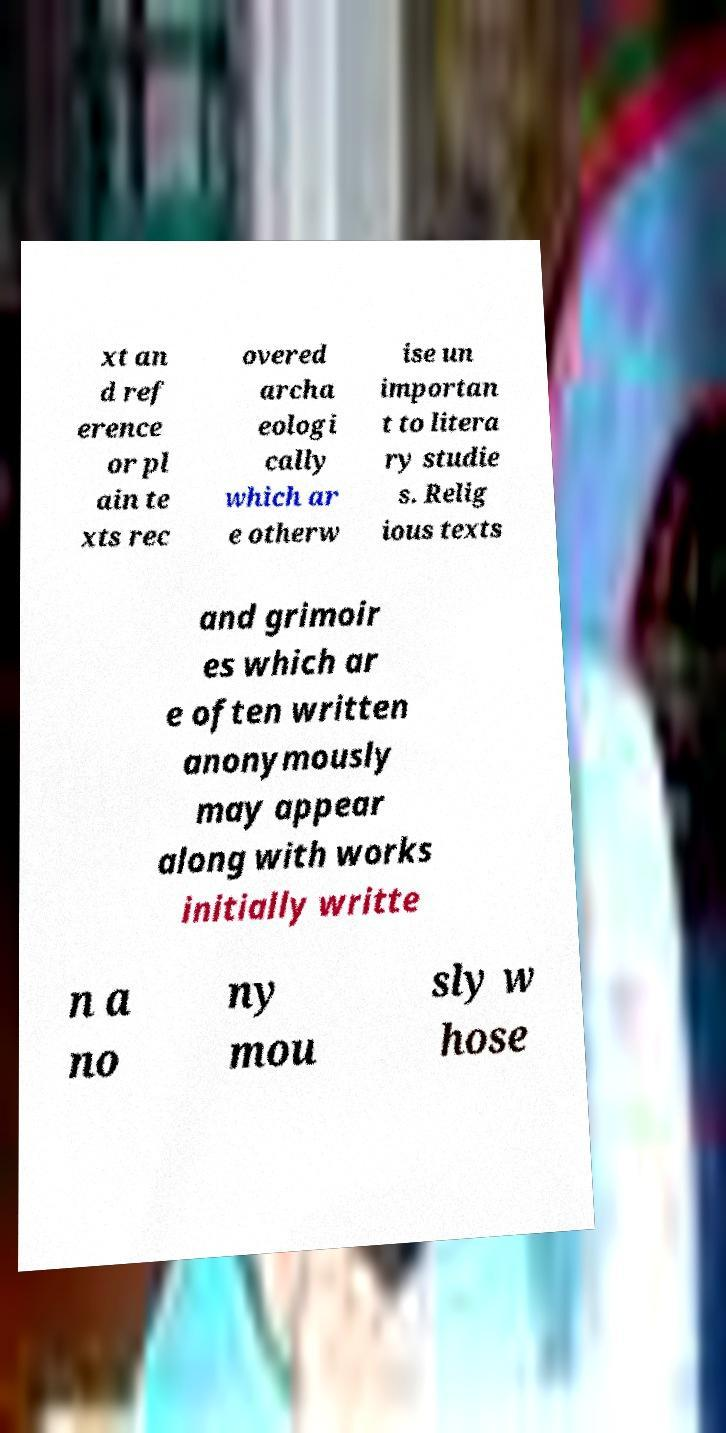Could you extract and type out the text from this image? xt an d ref erence or pl ain te xts rec overed archa eologi cally which ar e otherw ise un importan t to litera ry studie s. Relig ious texts and grimoir es which ar e often written anonymously may appear along with works initially writte n a no ny mou sly w hose 